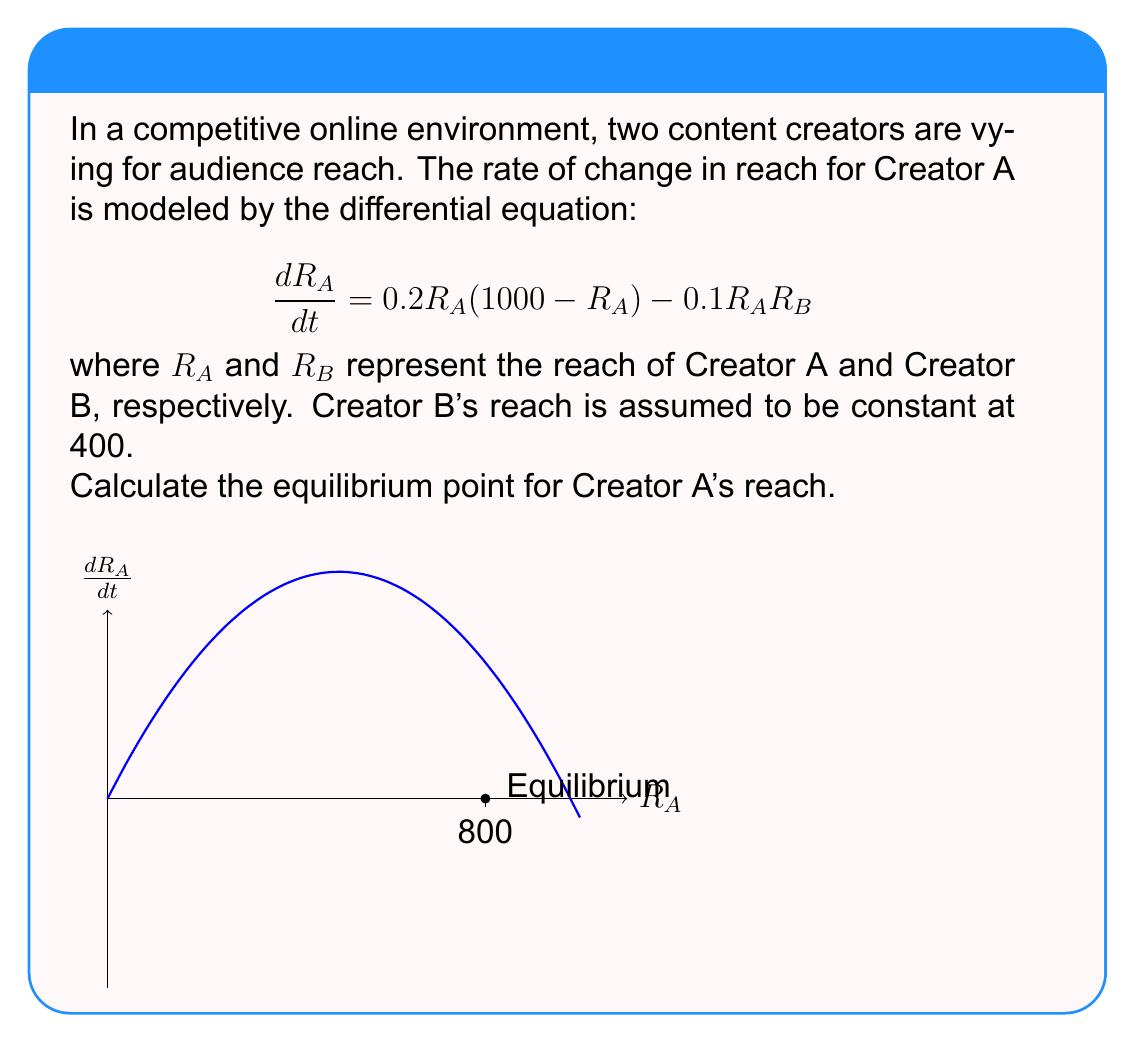Solve this math problem. To find the equilibrium point, we need to set $\frac{dR_A}{dt} = 0$ and solve for $R_A$.

1) Set the equation to zero:
   $$0 = 0.2R_A(1000 - R_A) - 0.1R_AR_B$$

2) Substitute $R_B = 400$:
   $$0 = 0.2R_A(1000 - R_A) - 0.1R_A(400)$$

3) Expand the equation:
   $$0 = 200R_A - 0.2R_A^2 - 40R_A$$

4) Simplify:
   $$0 = 160R_A - 0.2R_A^2$$

5) Factor out $R_A$:
   $$0 = R_A(160 - 0.2R_A)$$

6) Solve for $R_A$:
   Either $R_A = 0$ or $160 - 0.2R_A = 0$

7) For the non-zero solution:
   $$160 = 0.2R_A$$
   $$R_A = 800$$

Therefore, the equilibrium point for Creator A's reach is 800.
Answer: $R_A = 800$ 